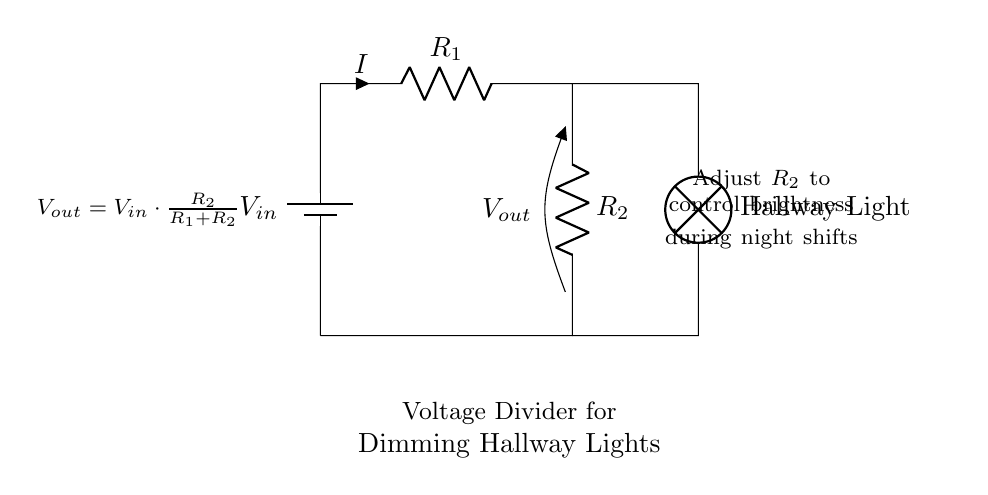What is the input voltage (V_in) represented in the diagram? The diagram does not specify a numerical value for the input voltage, but generally, it is indicated as V_in, which stands for the voltage supplied by the battery.
Answer: V_in What are the two resistors in the voltage divider? The diagram shows two resistors labeled R_1 and R_2. These resistors are the components that define the voltage division in the circuit.
Answer: R_1 and R_2 What is the output voltage (V_out) formula according to the diagram? The formula provided in the diagram is V_out = V_in * (R_2 / (R_1 + R_2)), which defines how V_out is calculated based on the resistances and input voltage.
Answer: V_out = V_in * (R_2 / (R_1 + R_2)) How can adjusting R_2 affect the hallway light? Adjusting R_2 changes the ratio of the resistances in the voltage divider, which in turn alters the output voltage (V_out) and thus the brightness of the hallway light. Higher R_2 leads to brighter light, while lower R_2 results in dimmer light.
Answer: It controls brightness Why is a voltage divider used for dimming lights in hospitals? A voltage divider is used because it allows for a simple and effective way to adjust the voltage supplied to the lamps for optimal brightness during night shifts, ensuring minimal disturbance to patients.
Answer: For optimal brightness control 